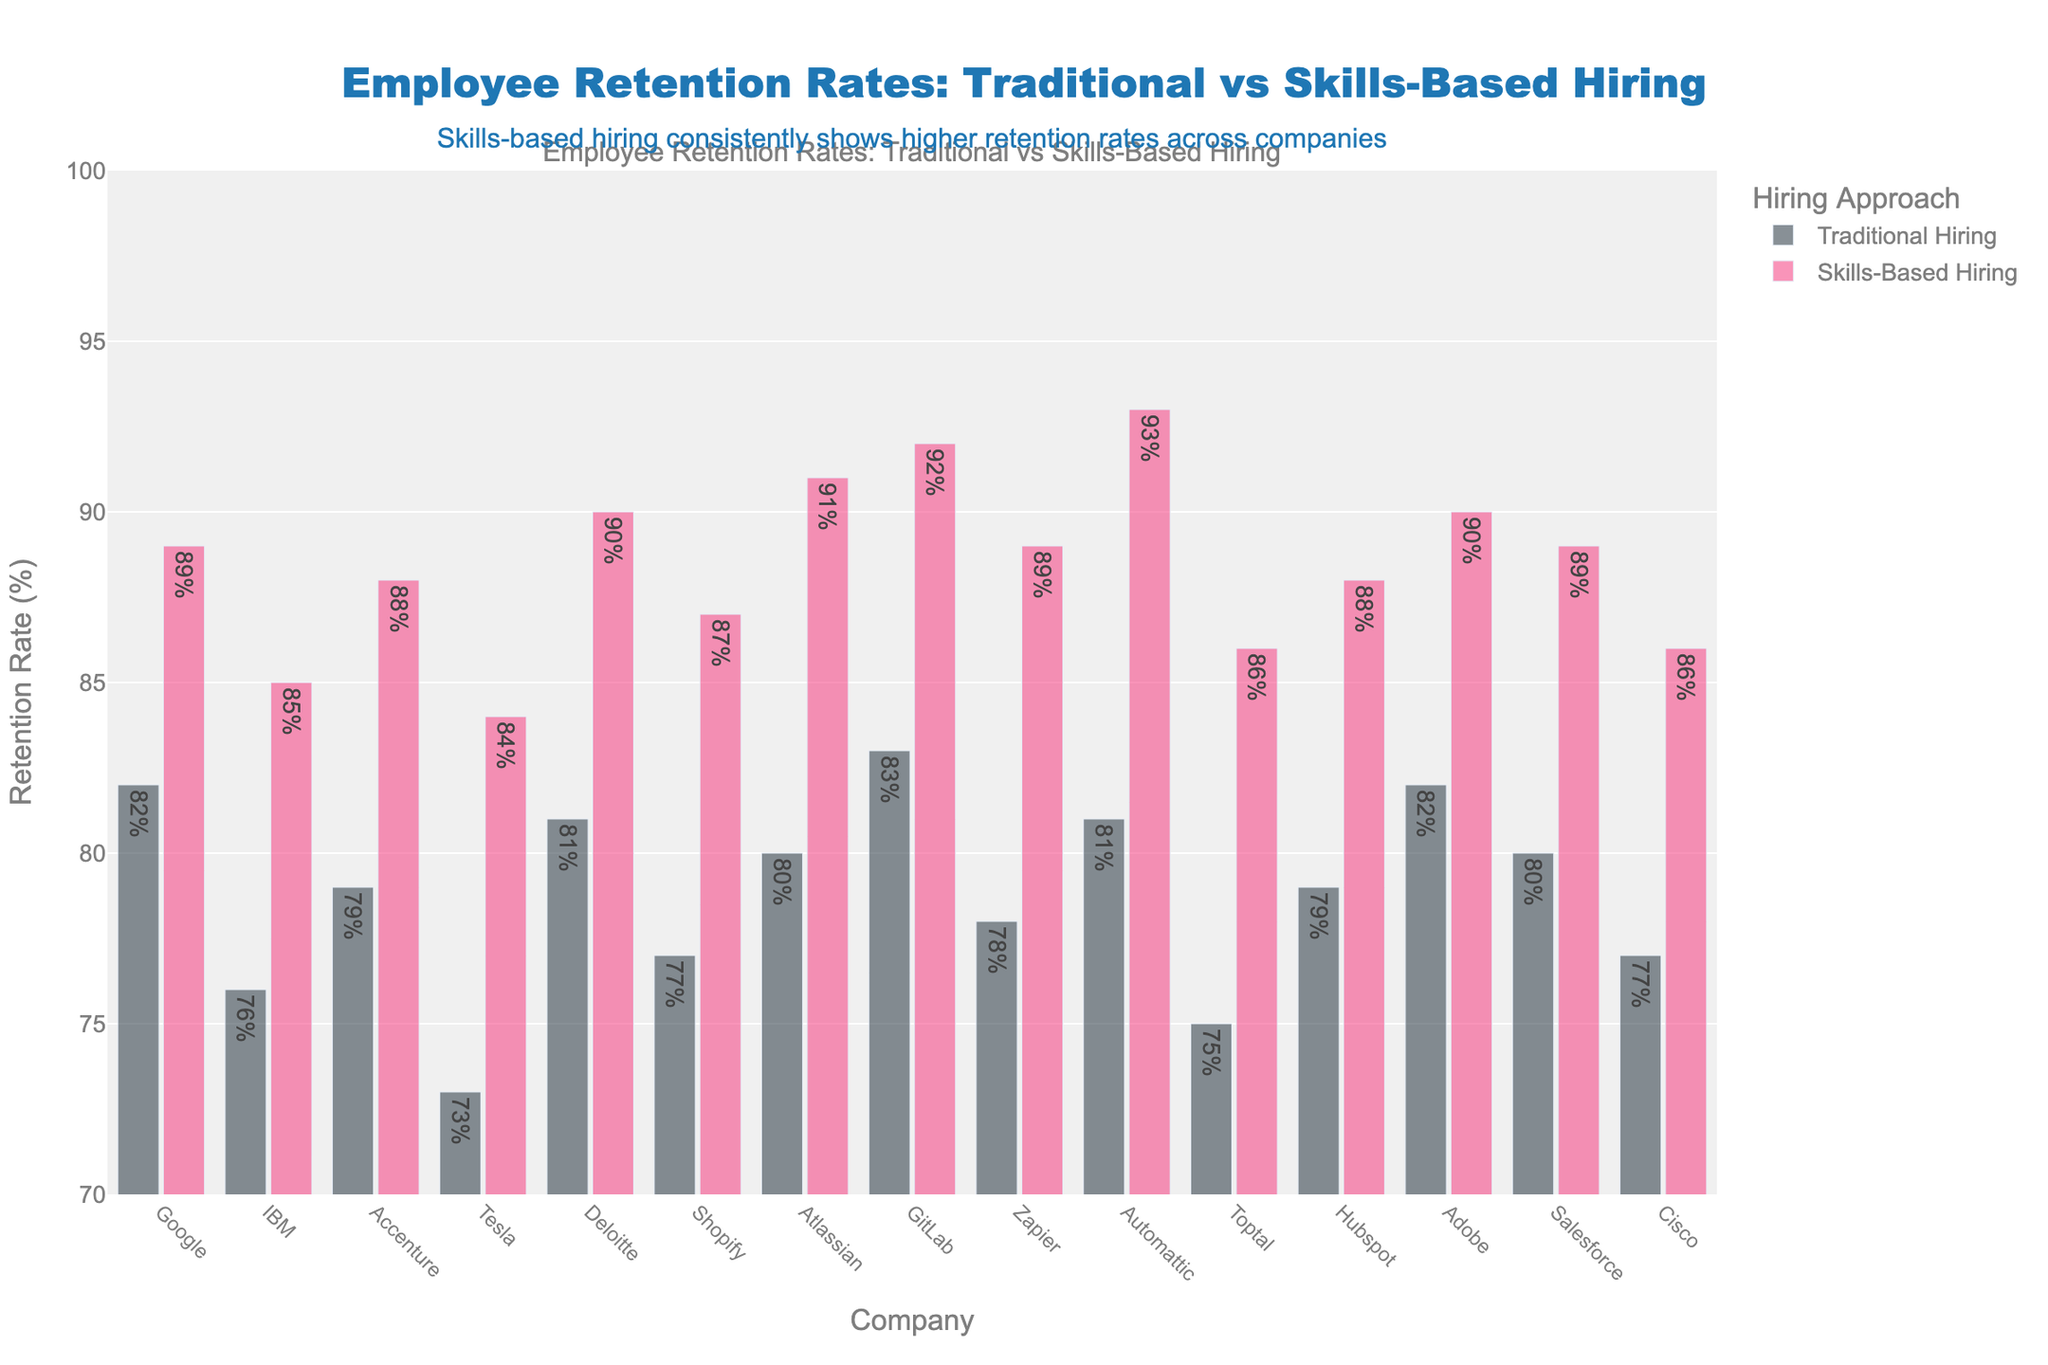What is the difference in retention rate between Google's traditional hiring and skills-based hiring approaches? Google's traditional hiring retention rate is 82%, while its skills-based hiring retention rate is 89%. The difference is 89% - 82% = 7%.
Answer: 7% Which company has the highest retention rate for skills-based hiring, and what is that rate? Automattic's skills-based hiring retention rate is 93%, which is the highest among the companies listed.
Answer: Automattic, 93% How many companies have a skills-based hiring retention rate of 90% or higher? To find this, look at the bar segments for skills-based hiring and count the bars that reach or exceed the 90% mark. They are Deloitte (90%), Atlassian (91%), GitLab (92%), Automattic (93%), and Adobe (90%). So, there are 5 companies.
Answer: 5 What is the average retention rate for traditional hiring across all companies? Sum all traditional hiring retention rates: (82+76+79+73+81+77+80+83+78+81+75+79+82+80+77) = 1123. There are 15 companies, so the average is 1123 / 15 ≈ 74.87%.
Answer: 74.87% Which company shows the biggest improvement in retention rate with skills-based hiring compared to traditional hiring? Compare the difference in retention rates for each company: Google (7%), IBM (9%), Accenture (9%), Tesla (11%), Deloitte (9%), Shopify (10%), Atlassian (11%), GitLab (9%), Zapier (11%), Automattic (12%), Toptal (11%), Hubspot (9%), Adobe (8%), Salesforce (9%), Cisco (9%). The largest difference is Automattic, with a 12% increase.
Answer: Automattic How does the retention rate of Zapier using traditional hiring compare with the skills-based hiring retention rate of IBM? Zapier's traditional hiring retention rate is 78%. IBM's skills-based hiring retention rate is 85%. So, Zapier's rate is lower by 85% - 78% = 7%.
Answer: 7% less What is the overall range of retention rates for skills-based hiring methods? The highest skills-based hiring retention rate is 93% (Automattic), and the lowest is 84% (Tesla). Therefore, the range is 93% - 84% = 9%.
Answer: 9% What is the median retention rate for skills-based hiring across all companies? To find the median, sort the rates and find the middle value. Sorted rates: [84, 85, 86, 86, 87, 88, 88, 89, 89, 89, 90, 90, 91, 92, 93]. With 15 companies, the median is the 8th value, which is 89%.
Answer: 89% Based on the figure, what can you infer about the overall trends in employee retention rates between traditional and skills-based hiring approaches? The visual differences show that skills-based hiring tends to result in higher retention rates compared to traditional hiring across all listed companies. This suggests that skills-based hiring might be a more effective approach for retaining employees.
Answer: Skills-based hiring has higher retention rates Is there any company where the traditional hiring retention rate exceeds 80% but has a smaller increase than 5% with skills-based hiring? Check companies where the traditional rate is more than 80%: Google (82%, 89% +7%), Deloitte (81%, 90% +9%), Atlassian (80%, 91% +11%), GitLab (83%, 92% +9%), Automattic (81%, 93% +12%), Adobe (82%, 90% +8%), Salesforce (80%, 89% +9%). None of these companies have an increase smaller than 5%.
Answer: No 